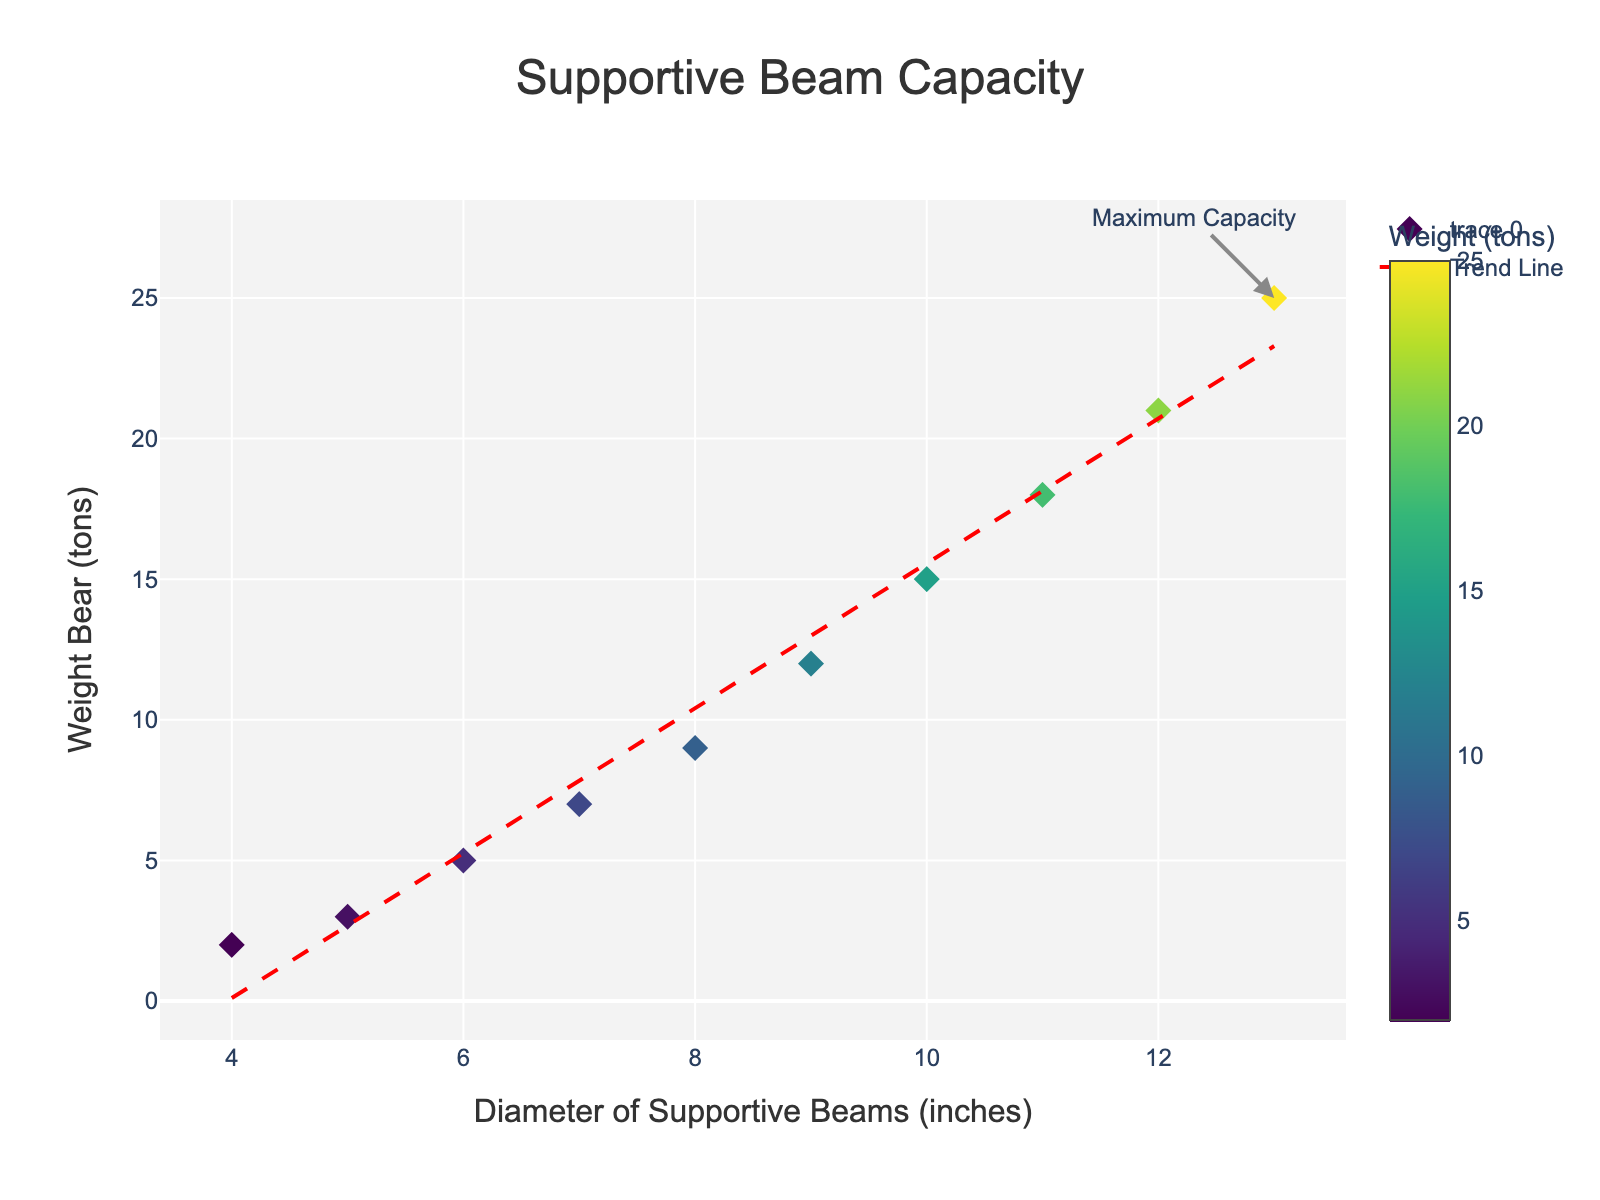What is the title of the scatter plot? The title of the scatter plot is centered at the top of the figure. It is labeled in a larger font for emphasis.
Answer: Supportive Beam Capacity What are the units used for the x-axis? The x-axis is labeled "Diameter of Supportive Beams" followed by the units in parentheses.
Answer: Inches How many data points are there in the scatter plot? Count the number of markers plotted on the scatter plot.
Answer: 10 What is the weight bearing capacity for a beam with a 7-inch diameter? Find the marker corresponding to the 7-inch diameter on the x-axis and read the y-axis value.
Answer: 7 tons What is the maximum weight bearing capacity shown in the plot? Identify the highest data point on the y-axis.
Answer: 25 tons What is the relationship trend between the diameter of supportive beams and the weight they bear? The scatter plot includes a trend line to highlight the relationship. As the diameter increases, the weight bearing capacity also increases.
Answer: Positive correlation How much weight can a beam with a diameter of 10 inches bear? Locate the data point where the x-axis value is 10 and read the corresponding y-axis value.
Answer: 15 tons What does the red dashed line in the plot represent? The red dashed line is added to the scatter plot to show the trend or predicted relationship between the variables.
Answer: Trend Line Which beam diameter corresponds to the annotation "Maximum Capacity"? The annotation points to a specific marker on the scatter plot.
Answer: 13 inches Among beams with diameters of 5 inches and 11 inches, which bears more weight and by how much? Compare the y-axis values for the data points corresponding to 5 and 11 inches. The 11-inch diameter beam bears 18 tons and the 5-inch diameter beam bears 3 tons. The difference is calculated by subtracting the smaller value from the larger one.
Answer: 15 tons 